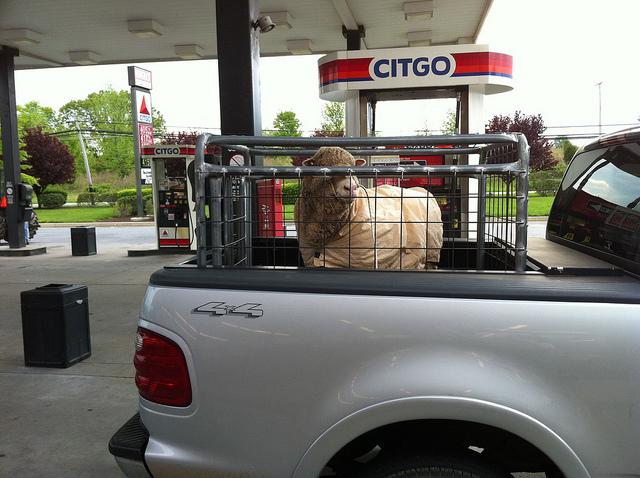What brand of gasoline is sold here?
Short answer required. Citgo. Is this a gas station?
Be succinct. Yes. Are there bananas in the back of that truck?
Write a very short answer. No. What is in the cage?
Give a very brief answer. Sheep. 